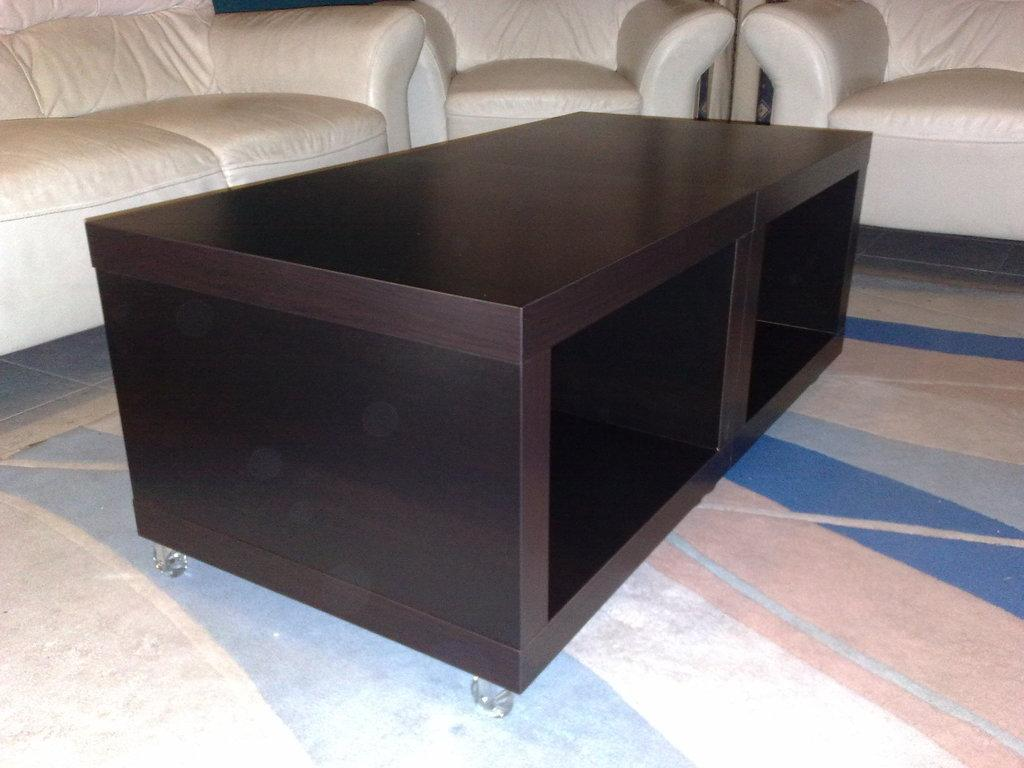What type of furniture is present in the image? There is a sofa and a table in the image. How many sofas are visible in the image? There are three sofas in the image. What is the color of the sofas? The sofas are white in color. What type of beast is depicted on the canvas hanging above the sofas in the image? There is no canvas or beast present in the image. How many ears can be seen on the sofas in the image? The sofas are inanimate objects and do not have ears. 